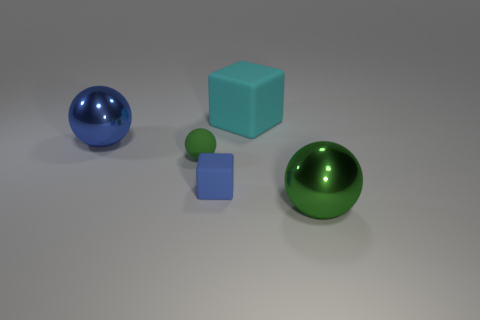What could be the possible materials of these objects? Based on their appearances, the objects seem to be made of different materials. The spheres have a glossy finish that could indicate a smooth, hard material like glass or polished metal. As for the cubes, their matte surface might suggest they are made of a substance like plastic or painted wood. The shiny reflections and the soft shadows give the impression of a studio-like setting, possibly for a 3D rendering or photographic session. 